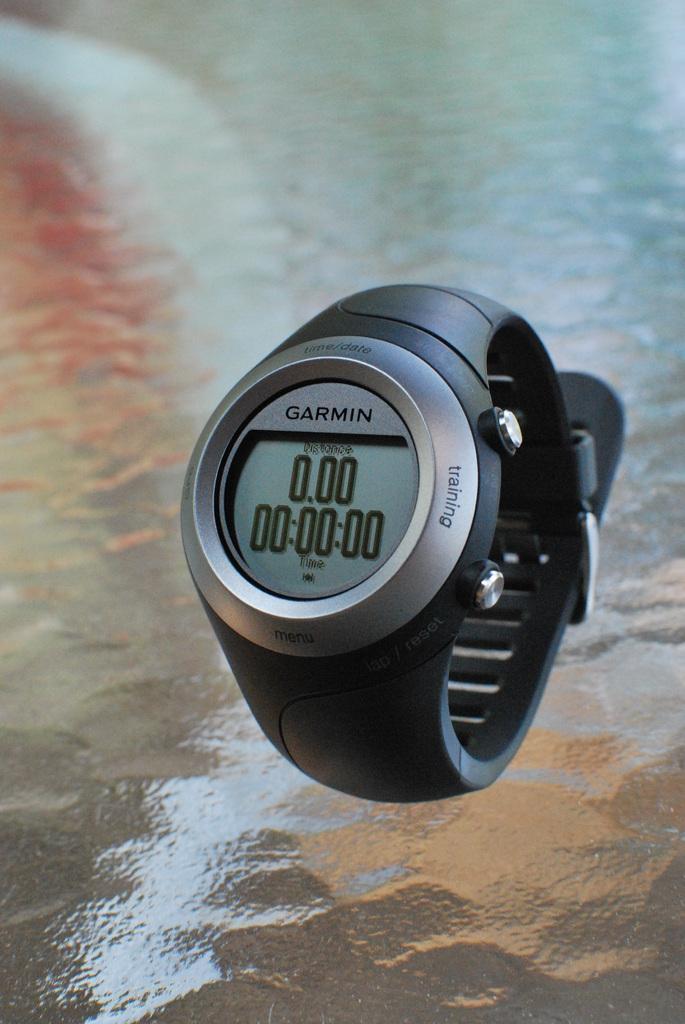Please provide a concise description of this image. In this image we can see a wrist watch on the glass surface. 